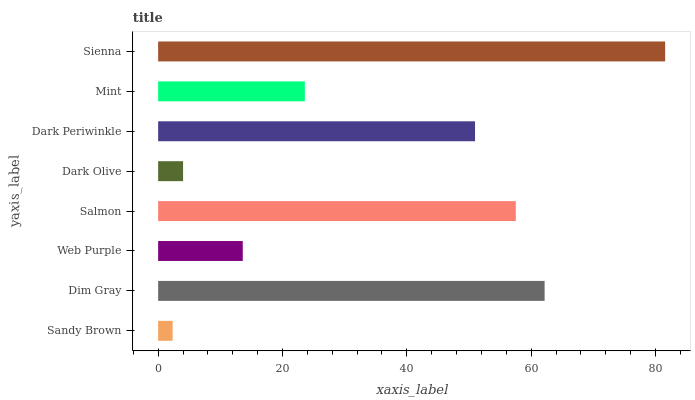Is Sandy Brown the minimum?
Answer yes or no. Yes. Is Sienna the maximum?
Answer yes or no. Yes. Is Dim Gray the minimum?
Answer yes or no. No. Is Dim Gray the maximum?
Answer yes or no. No. Is Dim Gray greater than Sandy Brown?
Answer yes or no. Yes. Is Sandy Brown less than Dim Gray?
Answer yes or no. Yes. Is Sandy Brown greater than Dim Gray?
Answer yes or no. No. Is Dim Gray less than Sandy Brown?
Answer yes or no. No. Is Dark Periwinkle the high median?
Answer yes or no. Yes. Is Mint the low median?
Answer yes or no. Yes. Is Dim Gray the high median?
Answer yes or no. No. Is Dark Periwinkle the low median?
Answer yes or no. No. 